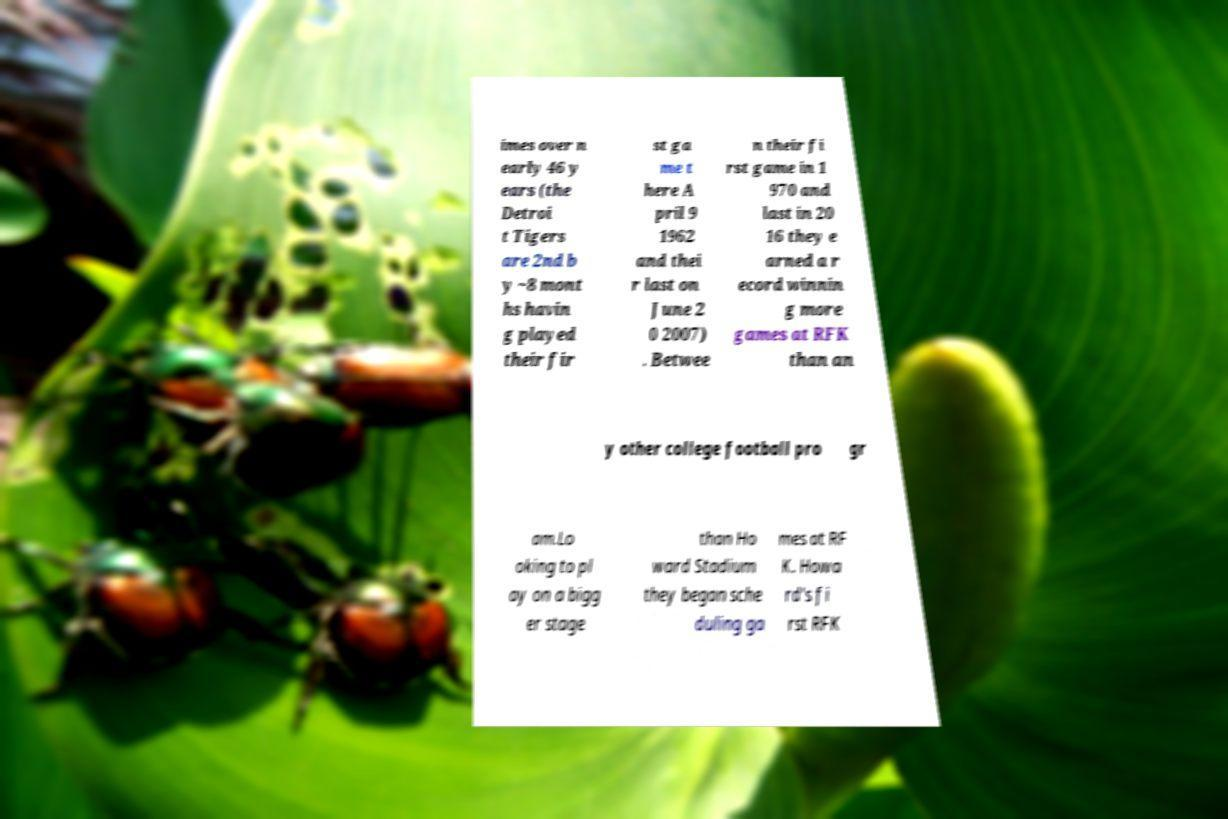Could you extract and type out the text from this image? imes over n early 46 y ears (the Detroi t Tigers are 2nd b y ~8 mont hs havin g played their fir st ga me t here A pril 9 1962 and thei r last on June 2 0 2007) . Betwee n their fi rst game in 1 970 and last in 20 16 they e arned a r ecord winnin g more games at RFK than an y other college football pro gr am.Lo oking to pl ay on a bigg er stage than Ho ward Stadium they began sche duling ga mes at RF K. Howa rd's fi rst RFK 